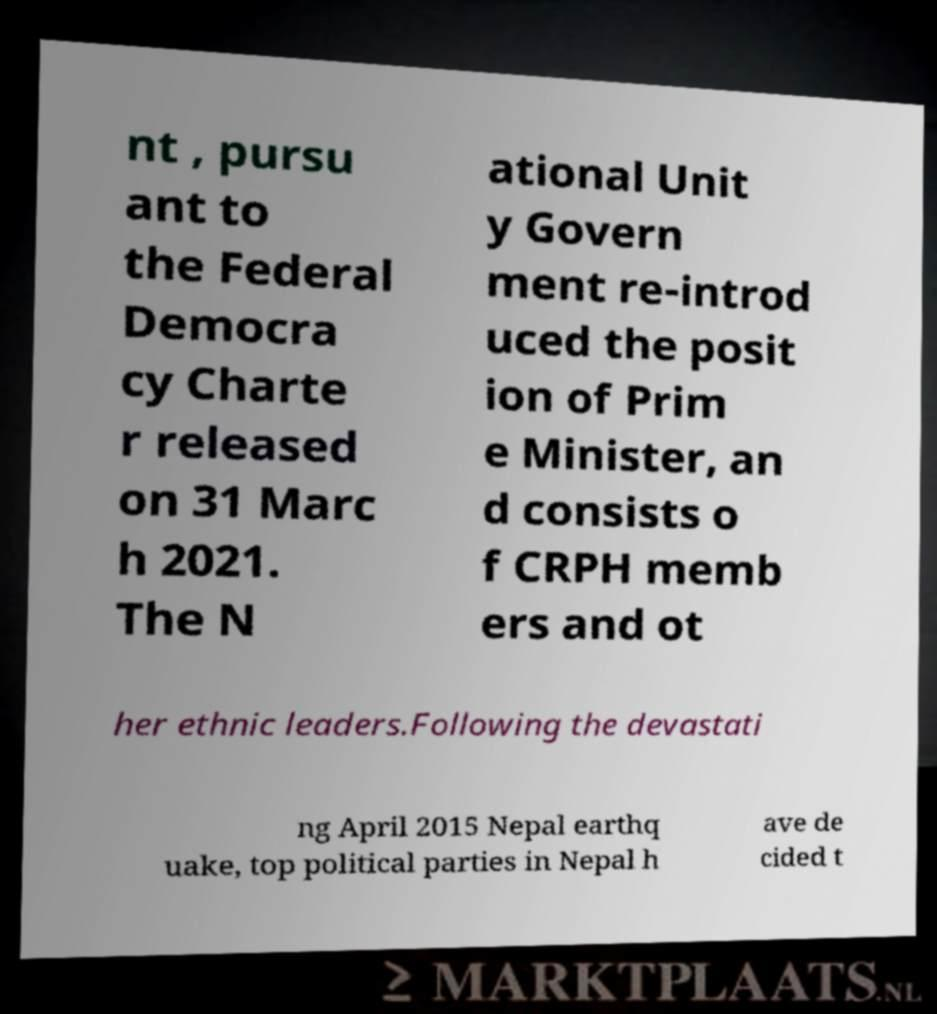Could you assist in decoding the text presented in this image and type it out clearly? nt , pursu ant to the Federal Democra cy Charte r released on 31 Marc h 2021. The N ational Unit y Govern ment re-introd uced the posit ion of Prim e Minister, an d consists o f CRPH memb ers and ot her ethnic leaders.Following the devastati ng April 2015 Nepal earthq uake, top political parties in Nepal h ave de cided t 